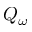<formula> <loc_0><loc_0><loc_500><loc_500>Q _ { \omega }</formula> 